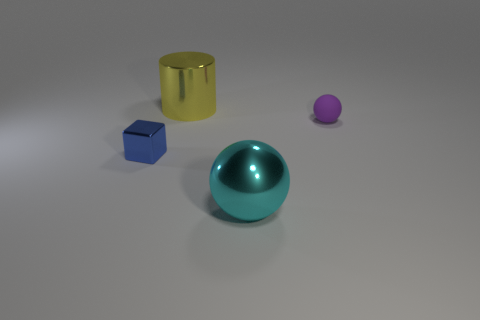Add 3 brown metallic objects. How many objects exist? 7 Subtract all cyan spheres. How many spheres are left? 1 Subtract all cylinders. How many objects are left? 3 Subtract 2 balls. How many balls are left? 0 Subtract all blue cylinders. How many brown cubes are left? 0 Subtract all tiny gray rubber cubes. Subtract all tiny purple rubber spheres. How many objects are left? 3 Add 3 yellow metallic objects. How many yellow metallic objects are left? 4 Add 1 tiny red cylinders. How many tiny red cylinders exist? 1 Subtract 0 green cylinders. How many objects are left? 4 Subtract all purple balls. Subtract all red cylinders. How many balls are left? 1 